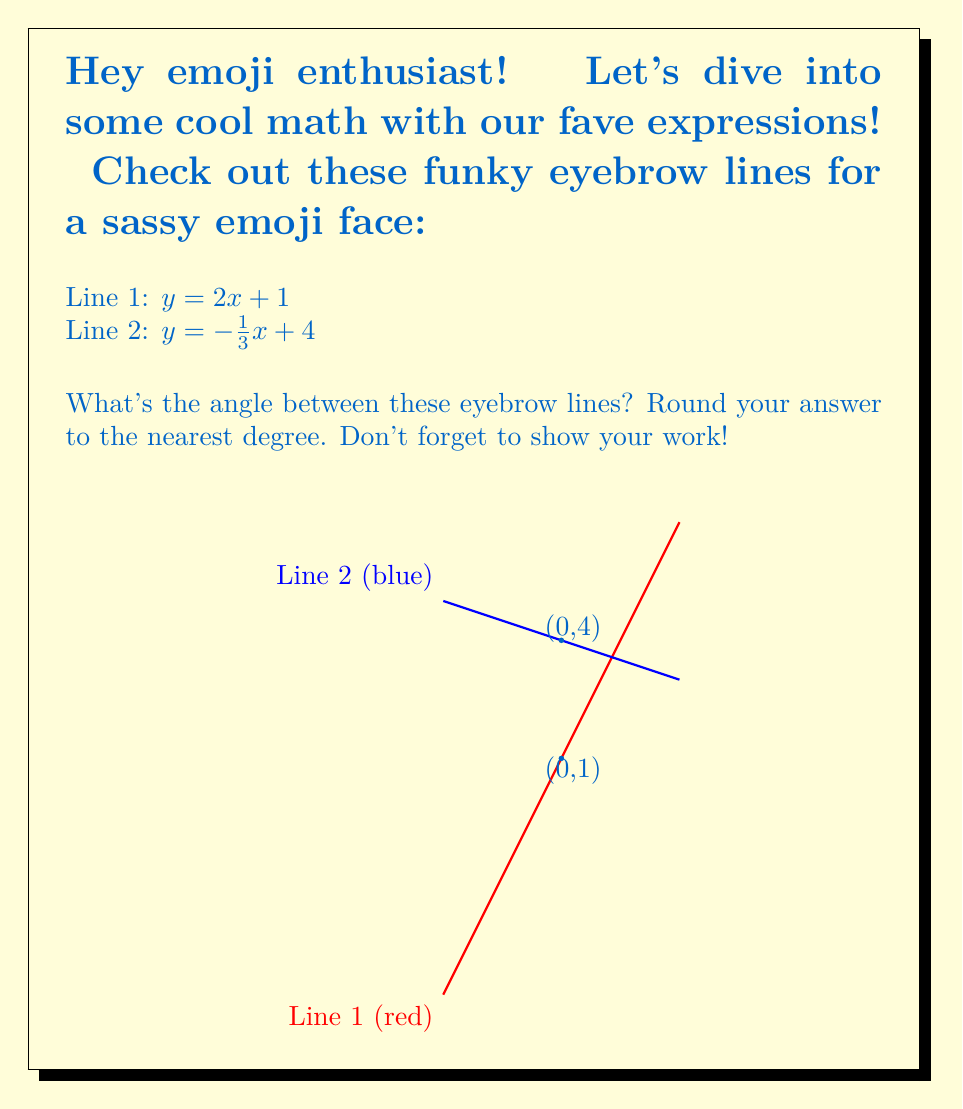Help me with this question. Okay, let's break this down step by step! 🚶‍♂️

1️⃣ First, we need to find the slopes of both lines:
   Line 1: $m_1 = 2$
   Line 2: $m_2 = -\frac{1}{3}$

2️⃣ Now, we can use the formula for the angle between two lines:
   $$\tan \theta = \left|\frac{m_1 - m_2}{1 + m_1m_2}\right|$$

3️⃣ Let's plug in our slopes:
   $$\tan \theta = \left|\frac{2 - (-\frac{1}{3})}{1 + 2(-\frac{1}{3})}\right|$$

4️⃣ Simplify the numerator and denominator:
   $$\tan \theta = \left|\frac{2 + \frac{1}{3}}{1 - \frac{2}{3}}\right| = \left|\frac{\frac{7}{3}}{\frac{1}{3}}\right| = 7$$

5️⃣ Now we need to find the angle using the inverse tangent function:
   $$\theta = \tan^{-1}(7)$$

6️⃣ Using a calculator (or your phone! 📱), we get:
   $$\theta \approx 81.87^\circ$$

7️⃣ Rounding to the nearest degree:
   $$\theta \approx 82^\circ$$

And there you have it! The angle between our sassy eyebrow lines is approximately 82°. That's one expressive emoji! 😜
Answer: 82° 